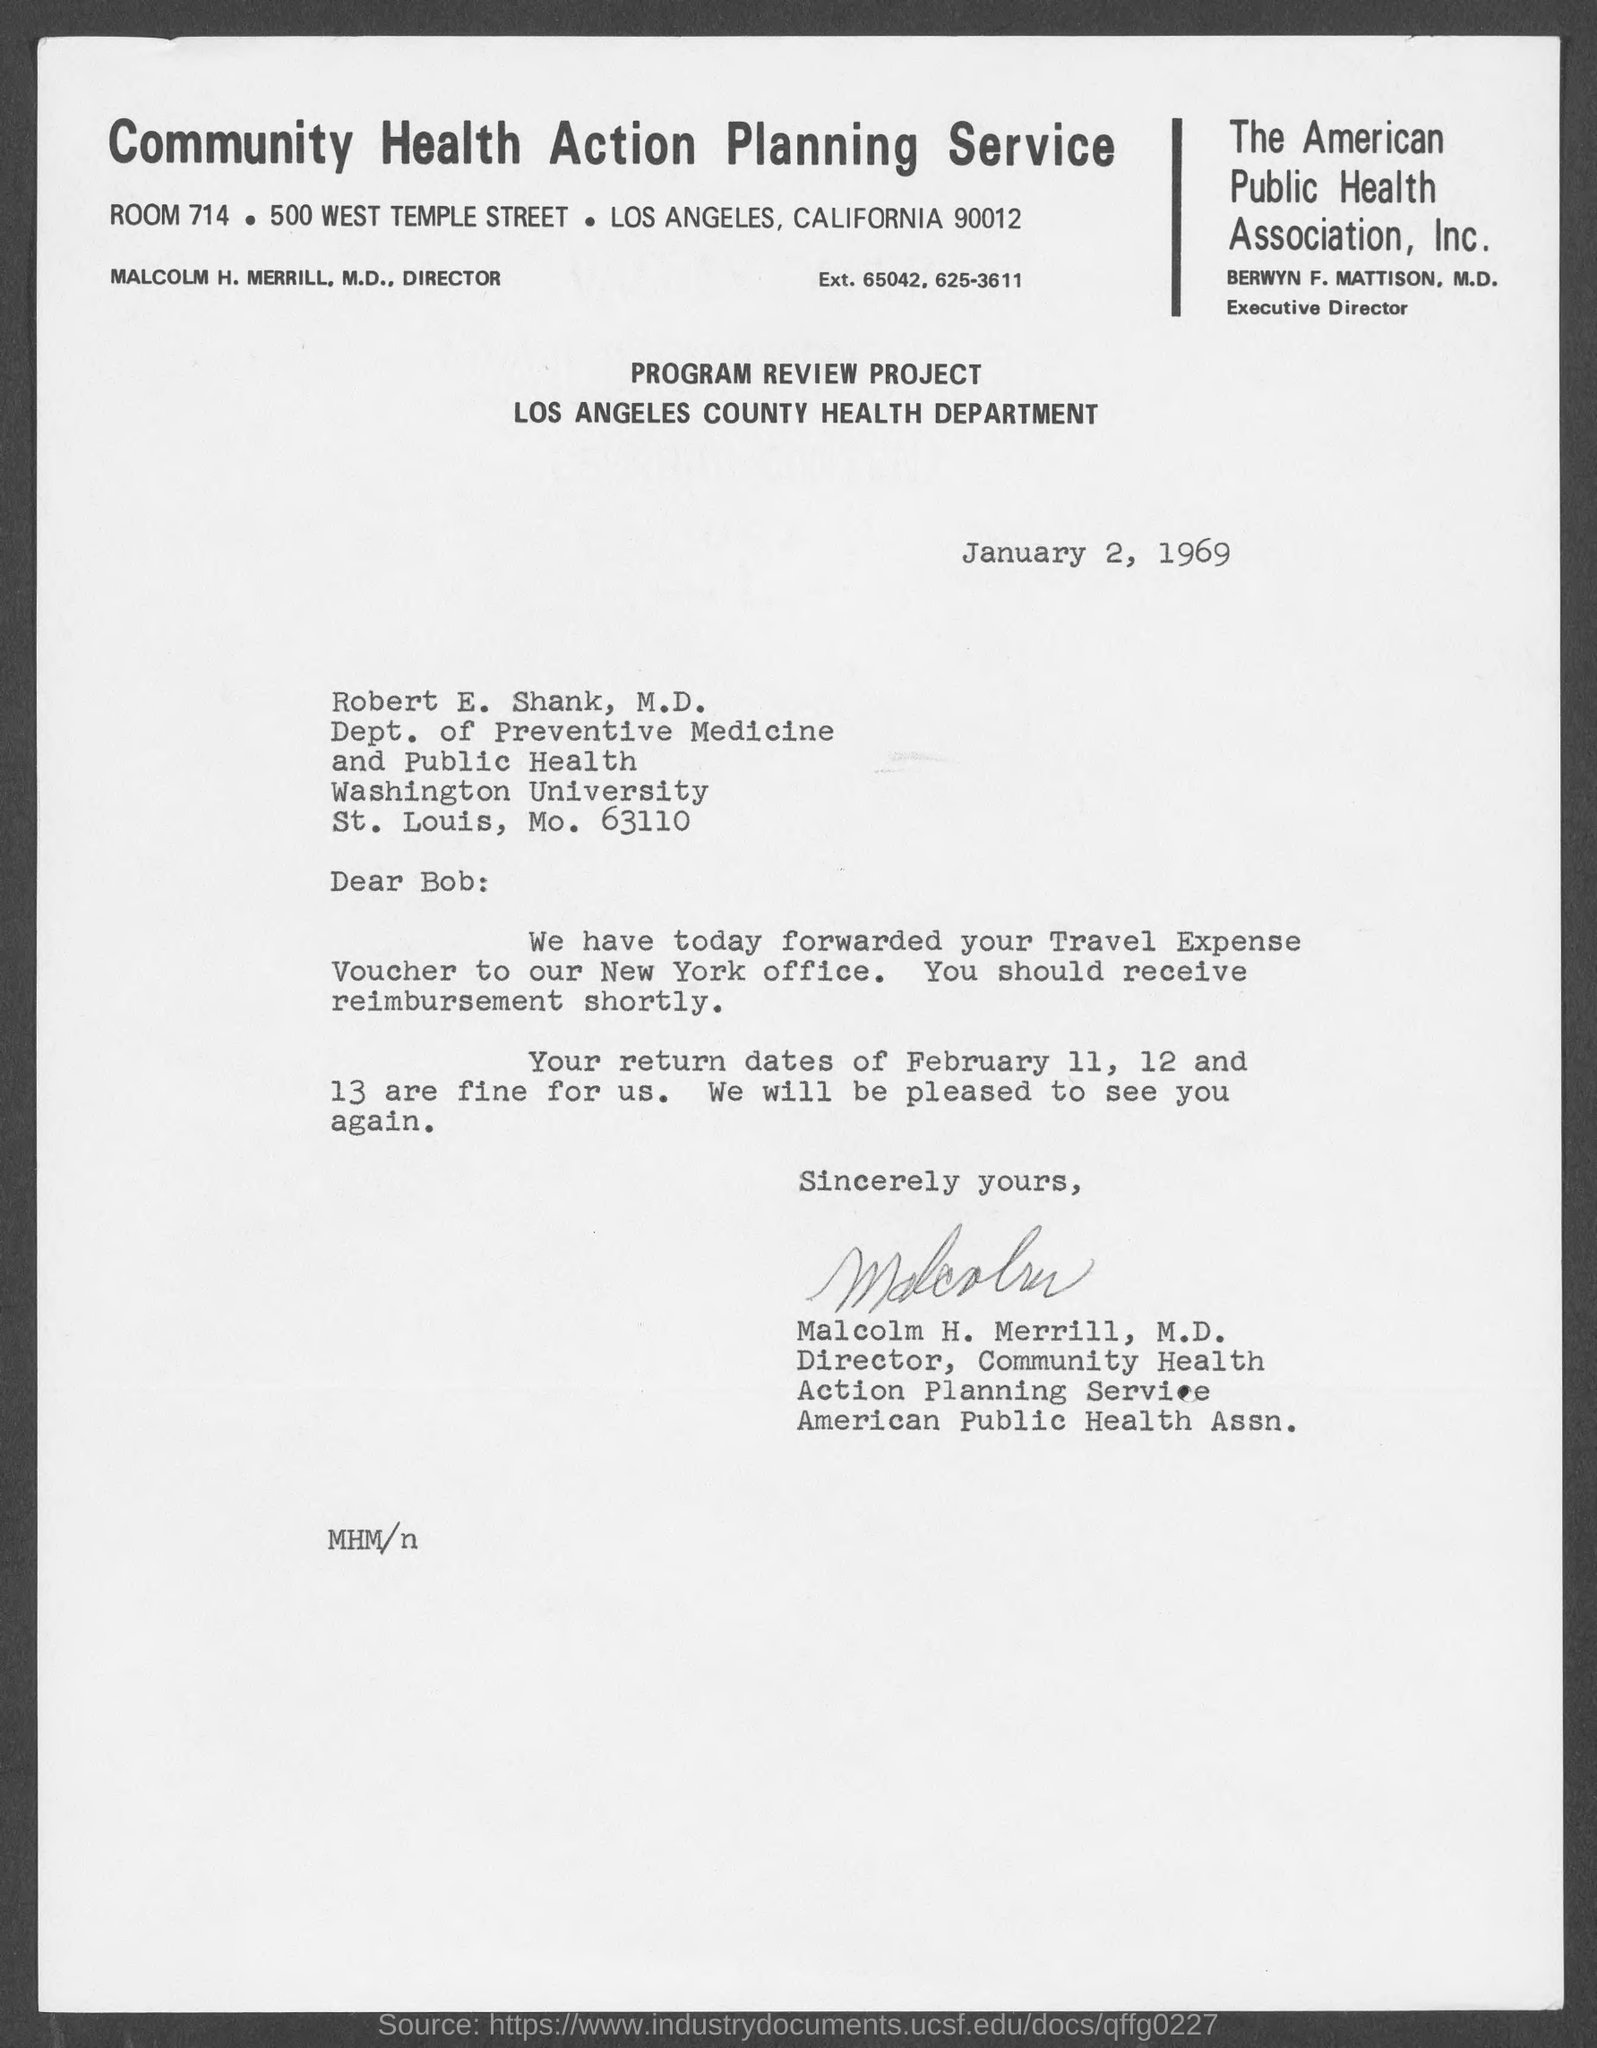Outline some significant characteristics in this image. Robert E. Shank is a member of the Department of Preventive Medicine and Public Health. The room number is 714, and a specific room was mentioned. The writer of this letter is Dr. Malcolm H. Merrill, as indicated in the letter itself. The date mentioned is January 2, 1969. Robert E. Shank is a member of Washington University. 